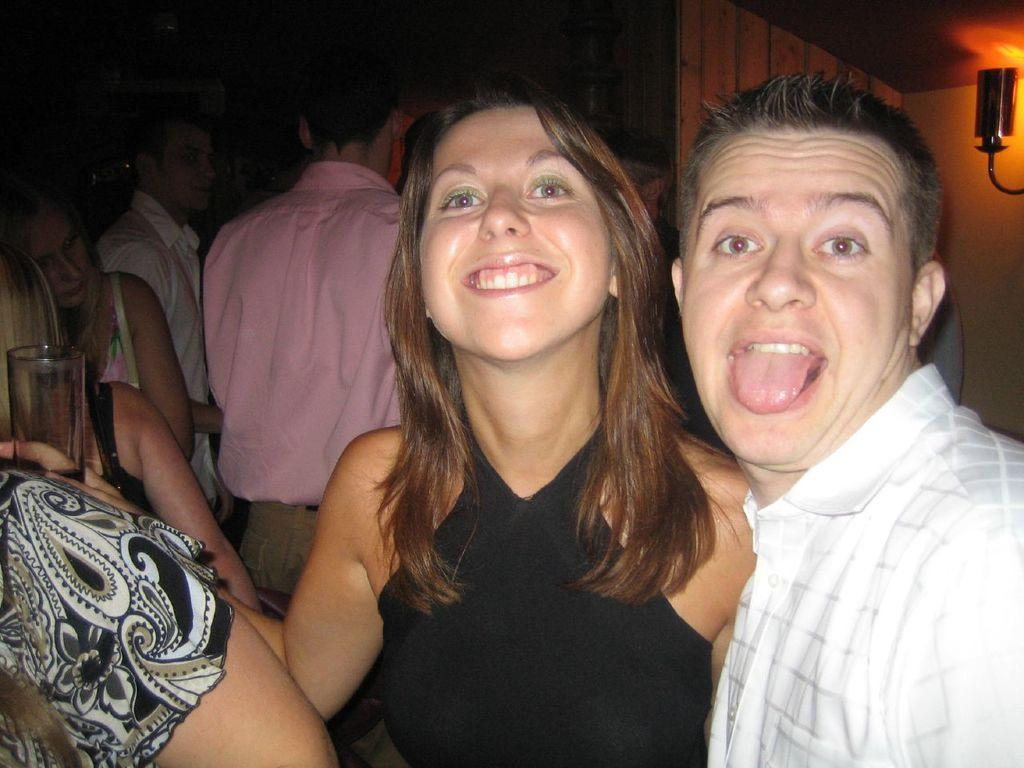How many people are standing in the image? There are 2 people standing in the image. What is the person on the right wearing? The person on the right is wearing a white shirt. What is the person on the left wearing? The person on the left is wearing a black dress. What is the person on the left holding? The person on the left is holding a glass. Can you describe the people visible in the background of the image? There are other people visible in the background of the image, but their clothing and actions are not specified in the provided facts. What type of grain is being used to make the plastic cups in the image? There is no grain or plastic cups present in the image. 